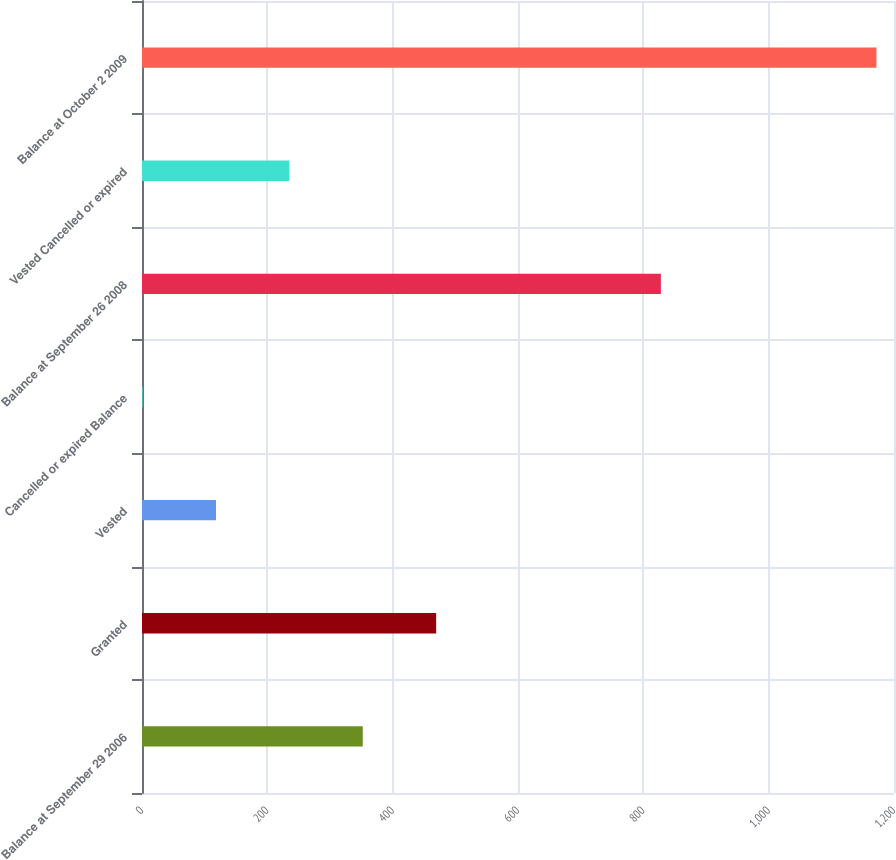Convert chart to OTSL. <chart><loc_0><loc_0><loc_500><loc_500><bar_chart><fcel>Balance at September 29 2006<fcel>Granted<fcel>Vested<fcel>Cancelled or expired Balance<fcel>Balance at September 26 2008<fcel>Vested Cancelled or expired<fcel>Balance at October 2 2009<nl><fcel>352.3<fcel>469.4<fcel>118.1<fcel>1<fcel>828<fcel>235.2<fcel>1172<nl></chart> 